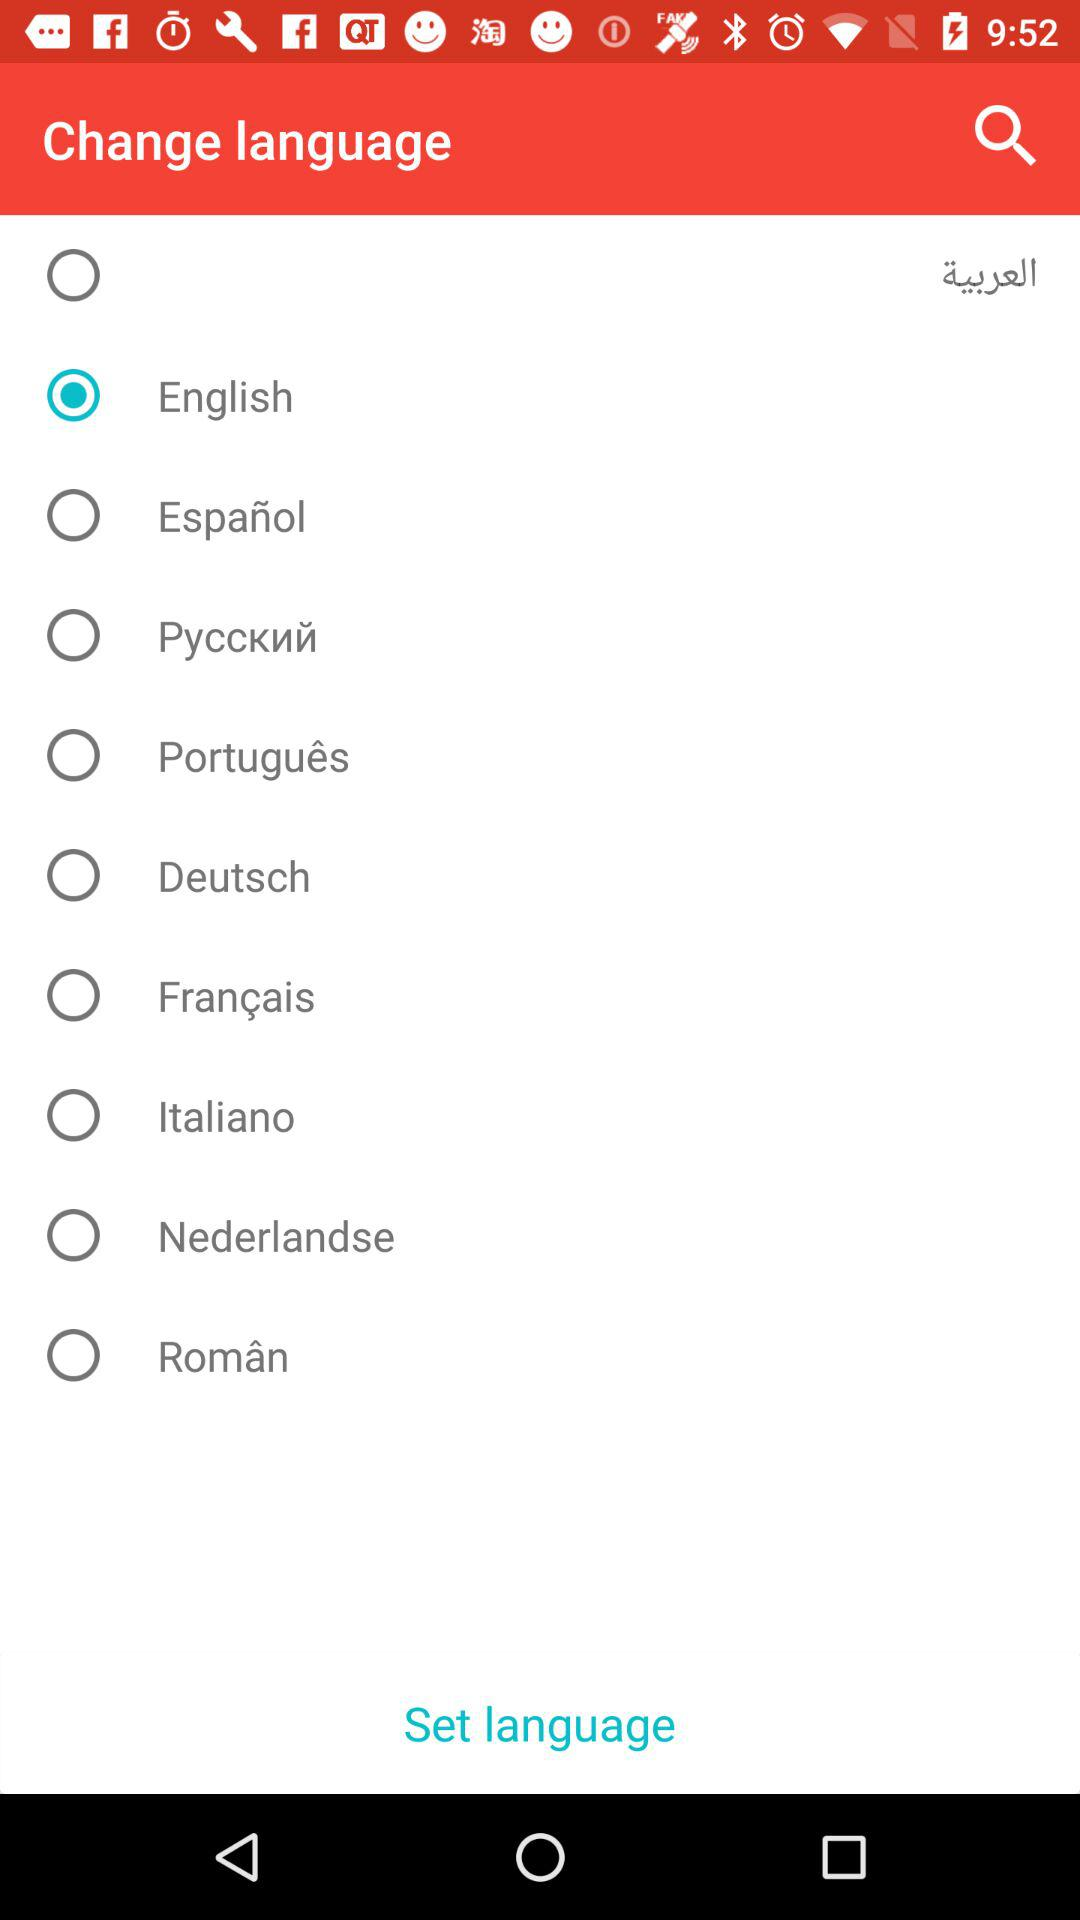Which language is selected? The selected language is English. 